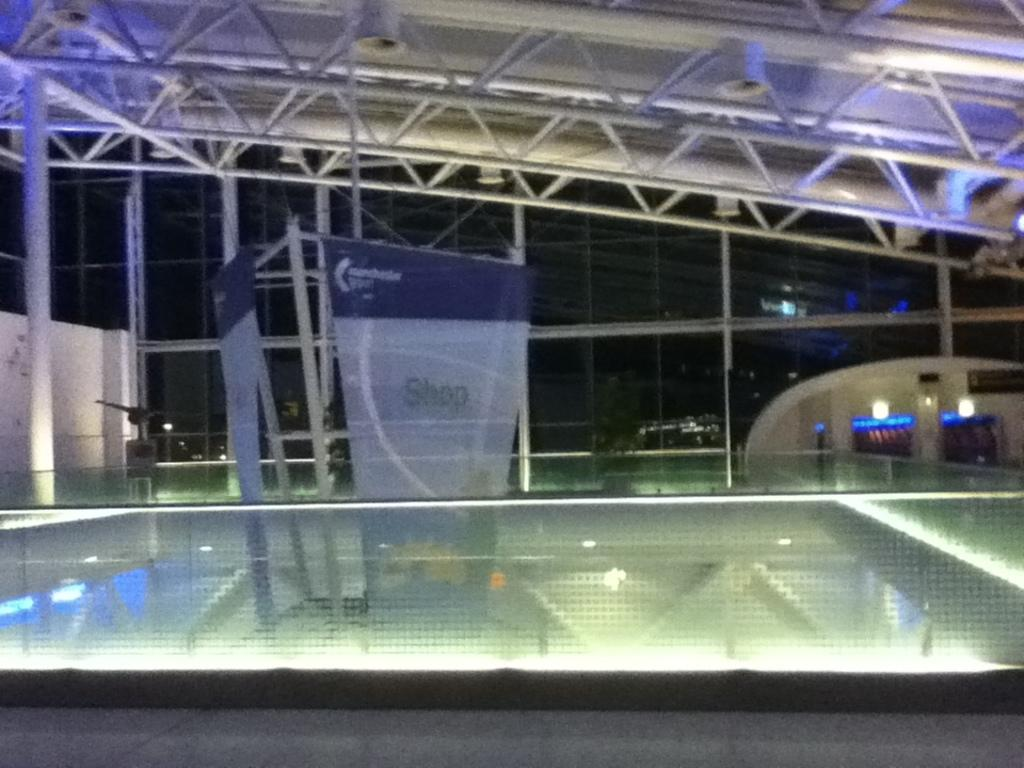How many banners can be seen in the image? There are two banners in the image. What type of wall is present in the image? There is a wall made of glass in the image. How many lights are visible in the image? There are two lights in the image. What other type of wall is present in the image? There is a wall in the image. What structure is present above the walls and banners? There is a roof in the image. Can you find an island in the image? There is no island present in the image. Is there an umbrella being used in the image? There is no umbrella present in the image. 